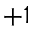Convert formula to latex. <formula><loc_0><loc_0><loc_500><loc_500>+ 1</formula> 